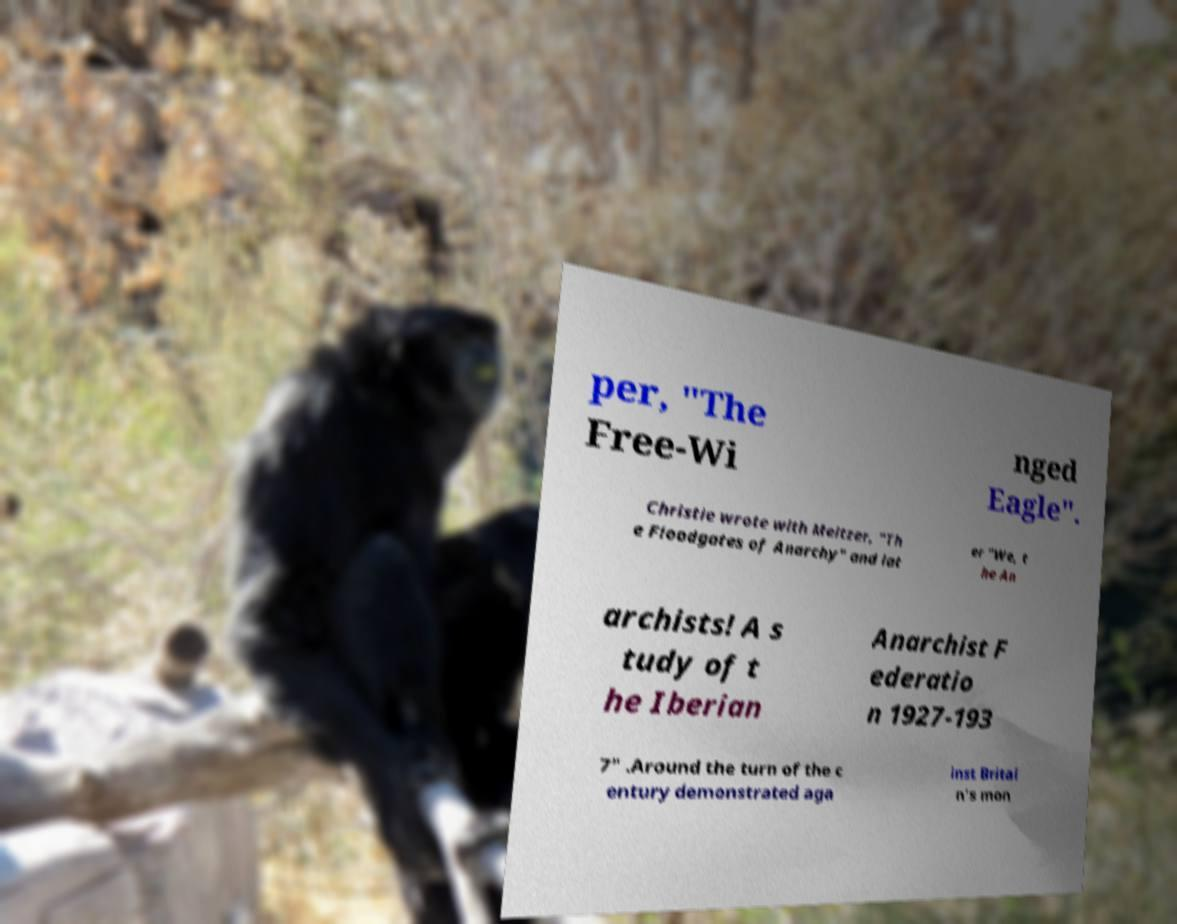Could you assist in decoding the text presented in this image and type it out clearly? per, "The Free-Wi nged Eagle". Christie wrote with Meltzer, "Th e Floodgates of Anarchy" and lat er "We, t he An archists! A s tudy of t he Iberian Anarchist F ederatio n 1927-193 7" .Around the turn of the c entury demonstrated aga inst Britai n's mon 